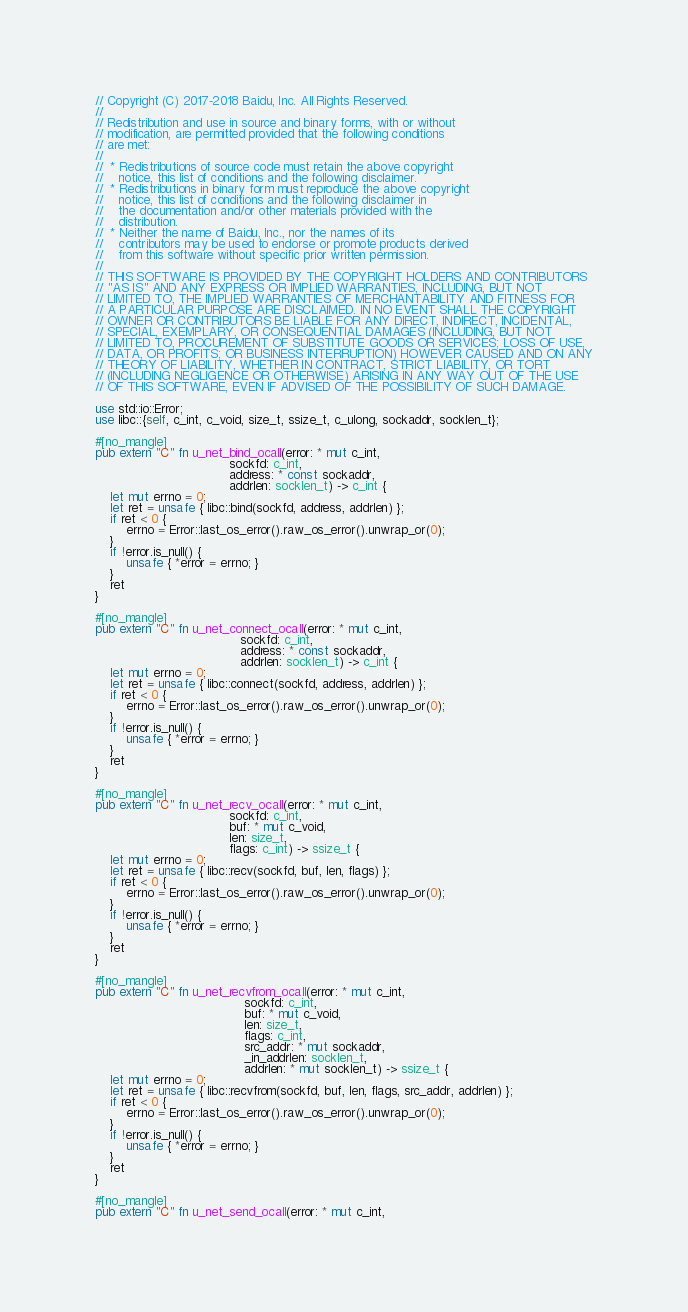<code> <loc_0><loc_0><loc_500><loc_500><_Rust_>// Copyright (C) 2017-2018 Baidu, Inc. All Rights Reserved.
//
// Redistribution and use in source and binary forms, with or without
// modification, are permitted provided that the following conditions
// are met:
//
//  * Redistributions of source code must retain the above copyright
//    notice, this list of conditions and the following disclaimer.
//  * Redistributions in binary form must reproduce the above copyright
//    notice, this list of conditions and the following disclaimer in
//    the documentation and/or other materials provided with the
//    distribution.
//  * Neither the name of Baidu, Inc., nor the names of its
//    contributors may be used to endorse or promote products derived
//    from this software without specific prior written permission.
//
// THIS SOFTWARE IS PROVIDED BY THE COPYRIGHT HOLDERS AND CONTRIBUTORS
// "AS IS" AND ANY EXPRESS OR IMPLIED WARRANTIES, INCLUDING, BUT NOT
// LIMITED TO, THE IMPLIED WARRANTIES OF MERCHANTABILITY AND FITNESS FOR
// A PARTICULAR PURPOSE ARE DISCLAIMED. IN NO EVENT SHALL THE COPYRIGHT
// OWNER OR CONTRIBUTORS BE LIABLE FOR ANY DIRECT, INDIRECT, INCIDENTAL,
// SPECIAL, EXEMPLARY, OR CONSEQUENTIAL DAMAGES (INCLUDING, BUT NOT
// LIMITED TO, PROCUREMENT OF SUBSTITUTE GOODS OR SERVICES; LOSS OF USE,
// DATA, OR PROFITS; OR BUSINESS INTERRUPTION) HOWEVER CAUSED AND ON ANY
// THEORY OF LIABILITY, WHETHER IN CONTRACT, STRICT LIABILITY, OR TORT
// (INCLUDING NEGLIGENCE OR OTHERWISE) ARISING IN ANY WAY OUT OF THE USE
// OF THIS SOFTWARE, EVEN IF ADVISED OF THE POSSIBILITY OF SUCH DAMAGE.

use std::io::Error;
use libc::{self, c_int, c_void, size_t, ssize_t, c_ulong, sockaddr, socklen_t};

#[no_mangle]
pub extern "C" fn u_net_bind_ocall(error: * mut c_int,
                                   sockfd: c_int,
                                   address: * const sockaddr,
                                   addrlen: socklen_t) -> c_int {
    let mut errno = 0;
    let ret = unsafe { libc::bind(sockfd, address, addrlen) };
    if ret < 0 {
        errno = Error::last_os_error().raw_os_error().unwrap_or(0);
    }
    if !error.is_null() {
        unsafe { *error = errno; }
    }
    ret
}

#[no_mangle]
pub extern "C" fn u_net_connect_ocall(error: * mut c_int,
                                      sockfd: c_int,
                                      address: * const sockaddr,
                                      addrlen: socklen_t) -> c_int {
    let mut errno = 0;
    let ret = unsafe { libc::connect(sockfd, address, addrlen) };
    if ret < 0 {
        errno = Error::last_os_error().raw_os_error().unwrap_or(0);
    }
    if !error.is_null() {
        unsafe { *error = errno; }
    }
    ret
}

#[no_mangle]
pub extern "C" fn u_net_recv_ocall(error: * mut c_int,
                                   sockfd: c_int,
                                   buf: * mut c_void,
                                   len: size_t,
                                   flags: c_int) -> ssize_t {
    let mut errno = 0;
    let ret = unsafe { libc::recv(sockfd, buf, len, flags) };
    if ret < 0 {
        errno = Error::last_os_error().raw_os_error().unwrap_or(0);
    }
    if !error.is_null() {
        unsafe { *error = errno; }
    }
    ret
}

#[no_mangle]
pub extern "C" fn u_net_recvfrom_ocall(error: * mut c_int,
                                       sockfd: c_int,
                                       buf: * mut c_void,
                                       len: size_t,
                                       flags: c_int,
                                       src_addr: * mut sockaddr,
                                       _in_addrlen: socklen_t,
                                       addrlen: * mut socklen_t) -> ssize_t {
    let mut errno = 0;
    let ret = unsafe { libc::recvfrom(sockfd, buf, len, flags, src_addr, addrlen) };
    if ret < 0 {
        errno = Error::last_os_error().raw_os_error().unwrap_or(0);
    }
    if !error.is_null() {
        unsafe { *error = errno; }
    }
    ret
}

#[no_mangle]
pub extern "C" fn u_net_send_ocall(error: * mut c_int,</code> 